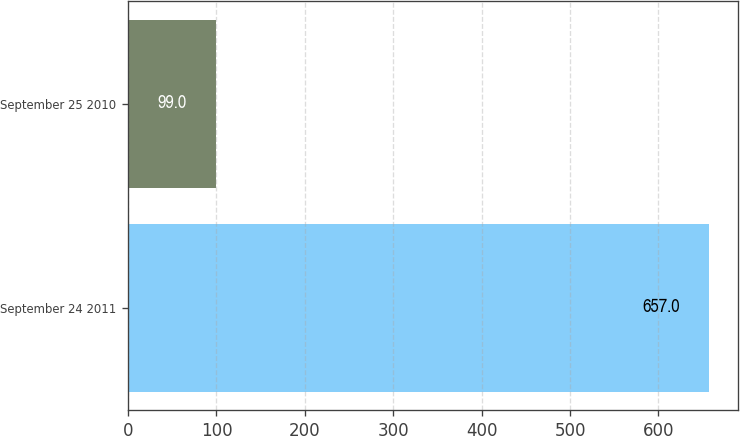Convert chart. <chart><loc_0><loc_0><loc_500><loc_500><bar_chart><fcel>September 24 2011<fcel>September 25 2010<nl><fcel>657<fcel>99<nl></chart> 